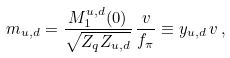Convert formula to latex. <formula><loc_0><loc_0><loc_500><loc_500>m _ { u , d } = \frac { M _ { 1 } ^ { u , d } ( 0 ) } { \sqrt { Z _ { q } Z _ { u , d } } } \, \frac { v } { f _ { \pi } } \equiv y _ { u , d } \, v \, ,</formula> 